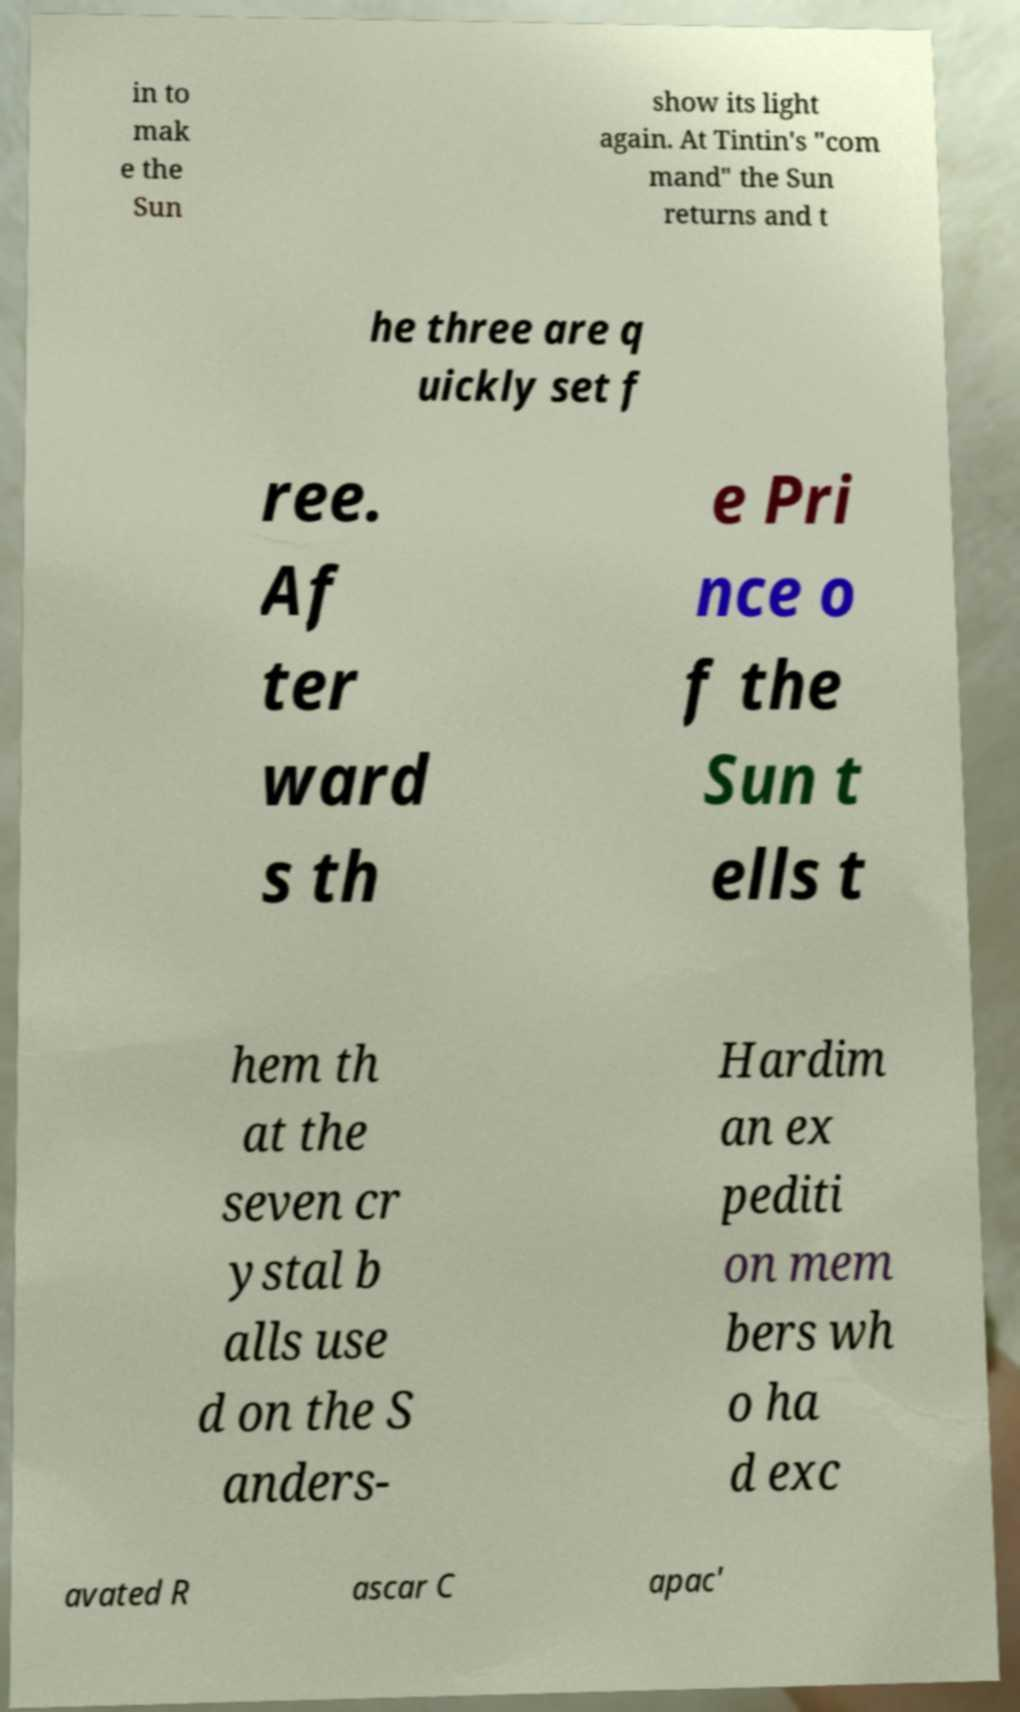For documentation purposes, I need the text within this image transcribed. Could you provide that? in to mak e the Sun show its light again. At Tintin's "com mand" the Sun returns and t he three are q uickly set f ree. Af ter ward s th e Pri nce o f the Sun t ells t hem th at the seven cr ystal b alls use d on the S anders- Hardim an ex pediti on mem bers wh o ha d exc avated R ascar C apac' 